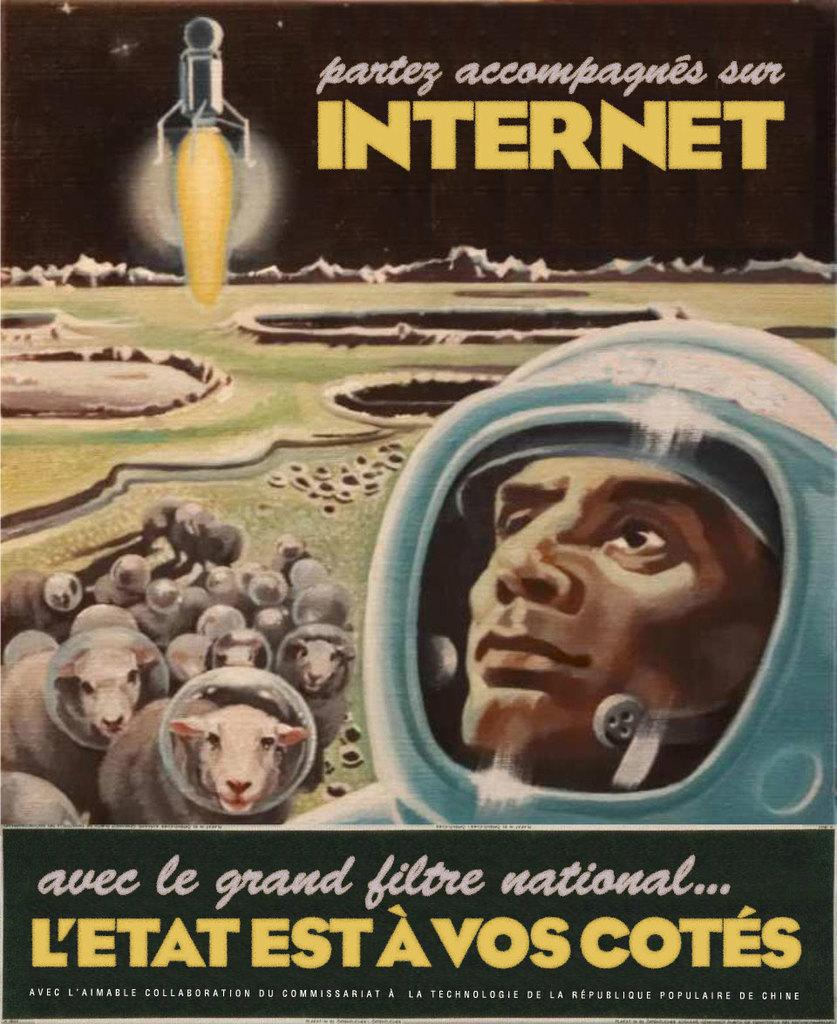<image>
Render a clear and concise summary of the photo. A movie poster that is featured by the Internet 